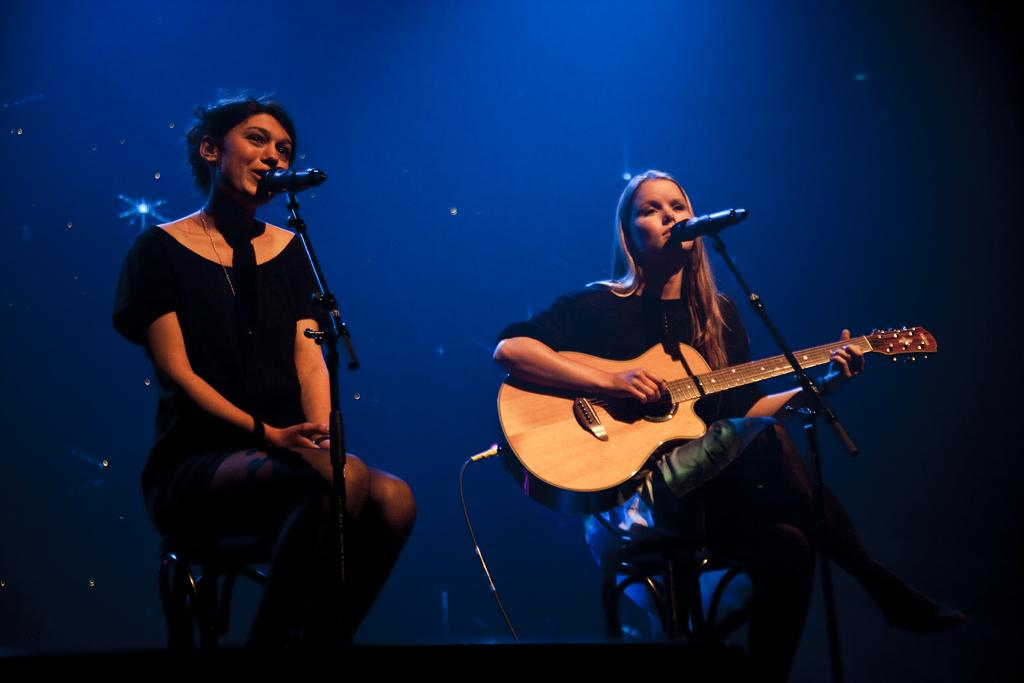What is the woman in the image doing? The woman is sitting in a chair and singing into a microphone. Can you describe the second woman in the image? The second woman is sitting in a chair and playing a guitar. What is the lighting condition in the image? The background of the image is dark. What type of base can be seen supporting the women in the image? There is no base visible in the image; the women are sitting in chairs. What fictional character might be present in the image? There is no indication of any fictional characters in the image. 